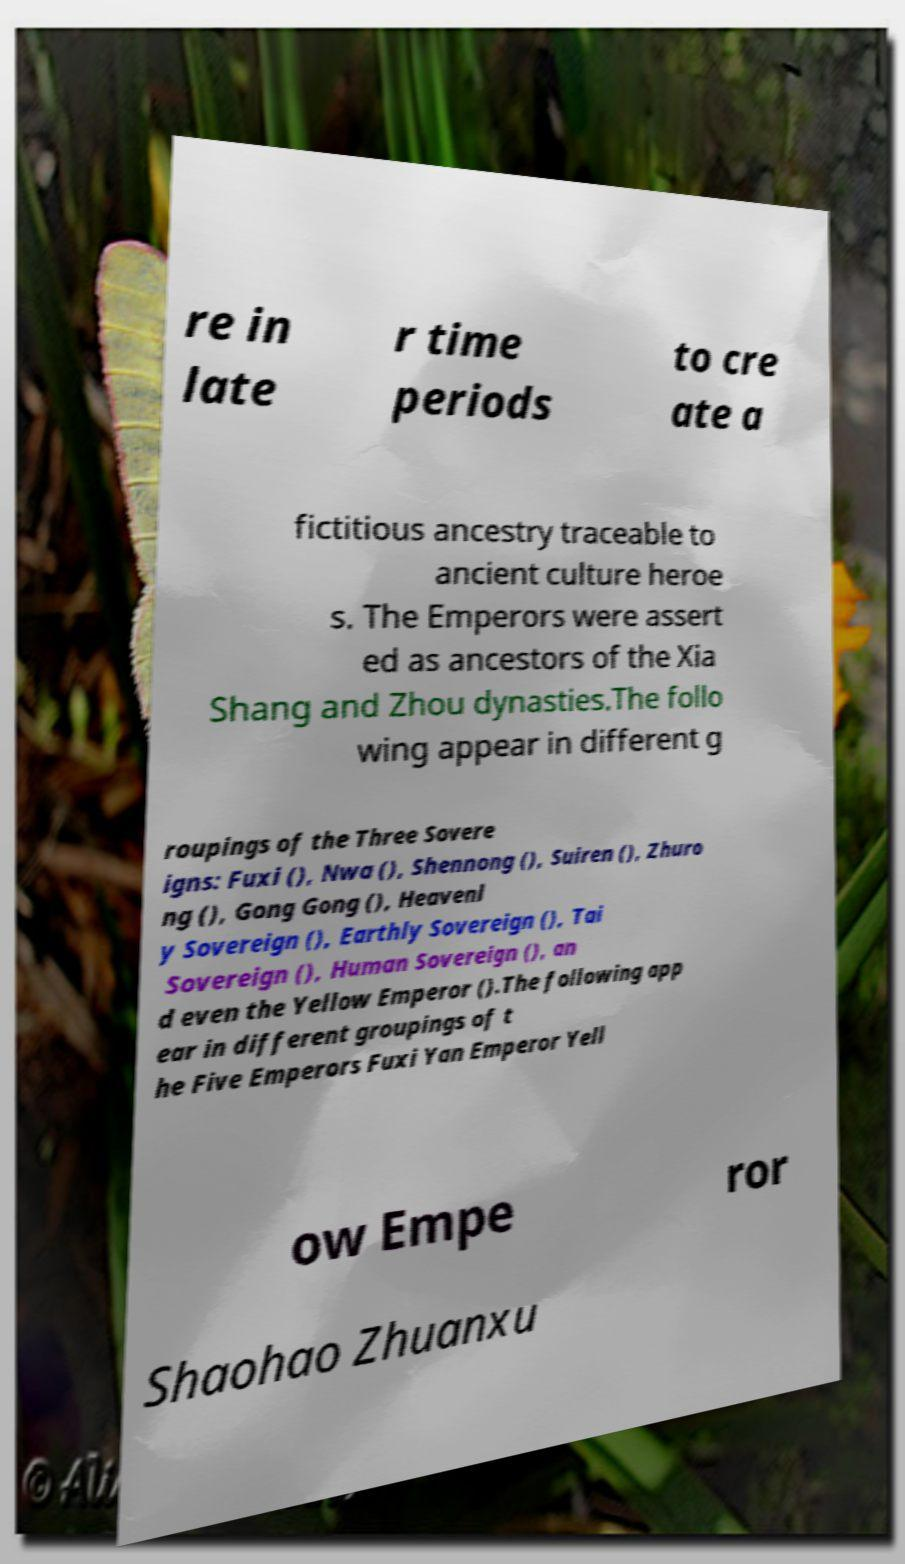Could you extract and type out the text from this image? re in late r time periods to cre ate a fictitious ancestry traceable to ancient culture heroe s. The Emperors were assert ed as ancestors of the Xia Shang and Zhou dynasties.The follo wing appear in different g roupings of the Three Sovere igns: Fuxi (), Nwa (), Shennong (), Suiren (), Zhuro ng (), Gong Gong (), Heavenl y Sovereign (), Earthly Sovereign (), Tai Sovereign (), Human Sovereign (), an d even the Yellow Emperor ().The following app ear in different groupings of t he Five Emperors Fuxi Yan Emperor Yell ow Empe ror Shaohao Zhuanxu 